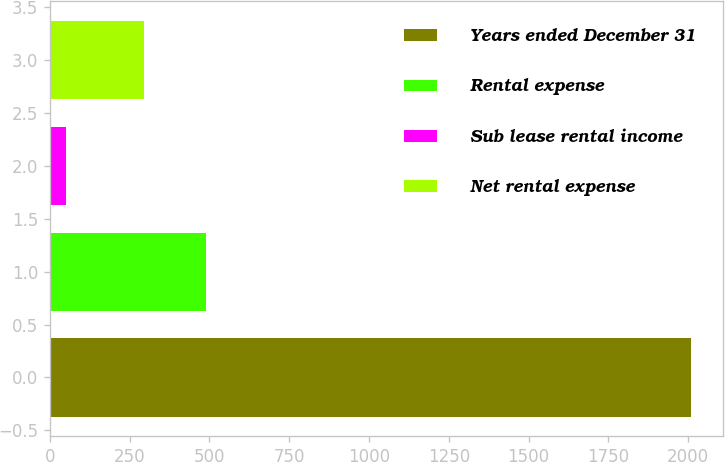<chart> <loc_0><loc_0><loc_500><loc_500><bar_chart><fcel>Years ended December 31<fcel>Rental expense<fcel>Sub lease rental income<fcel>Net rental expense<nl><fcel>2009<fcel>489.7<fcel>52<fcel>294<nl></chart> 